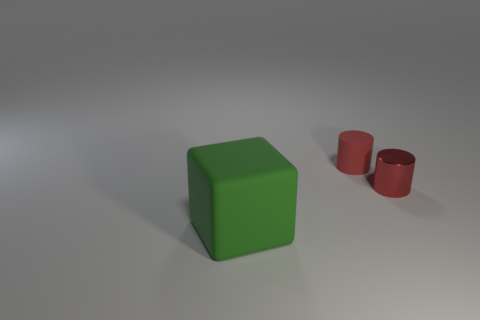Does the small matte object have the same color as the metallic cylinder?
Keep it short and to the point. Yes. There is a matte thing to the right of the big green object; does it have the same size as the thing that is in front of the red shiny object?
Make the answer very short. No. Are there an equal number of big things that are on the left side of the red rubber object and things to the left of the small red shiny cylinder?
Offer a very short reply. No. There is a metallic thing; does it have the same size as the matte object left of the small matte cylinder?
Keep it short and to the point. No. Is there a tiny cylinder to the right of the small cylinder to the right of the tiny red matte thing?
Provide a short and direct response. No. Are there any small red matte things that have the same shape as the small red metallic object?
Ensure brevity in your answer.  Yes. How many rubber objects are behind the small red cylinder that is on the left side of the small shiny thing that is to the right of the matte cylinder?
Keep it short and to the point. 0. Do the metal cylinder and the rubber object that is in front of the rubber cylinder have the same color?
Keep it short and to the point. No. What number of objects are either matte things that are behind the big thing or tiny red matte cylinders behind the red shiny thing?
Ensure brevity in your answer.  1. Are there more tiny matte objects in front of the large rubber block than small rubber things left of the small matte object?
Ensure brevity in your answer.  No. 